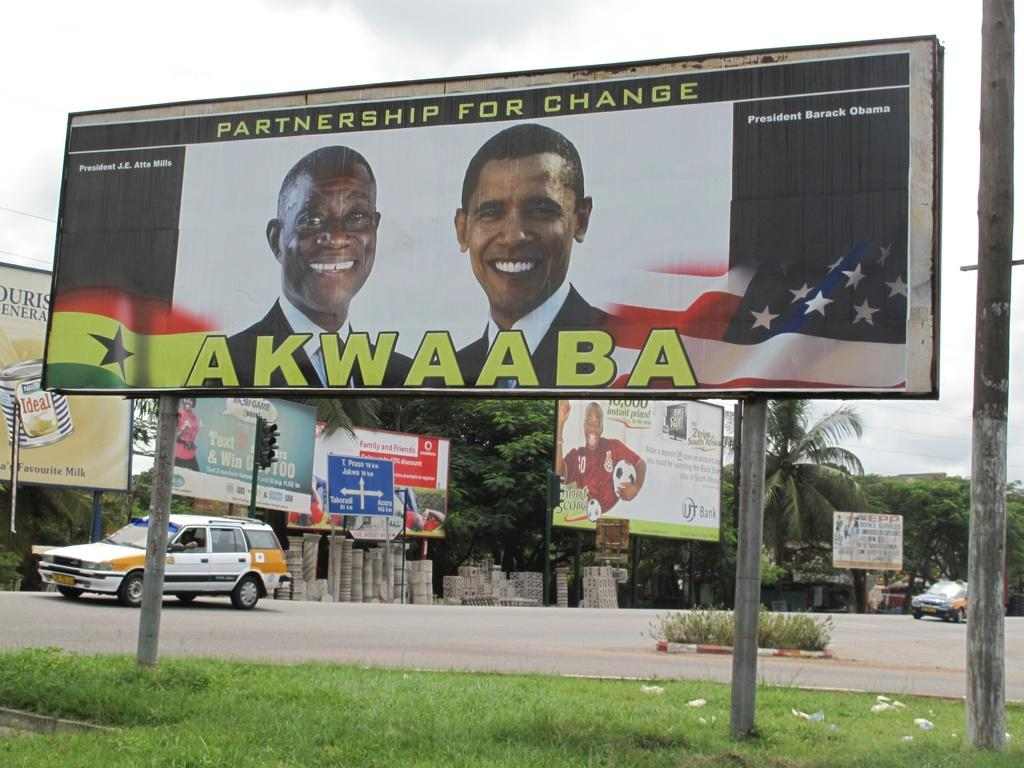<image>
Share a concise interpretation of the image provided. A billboard faturing former president Barack Obamba and an other man with the text akwaaba on the bottom. 